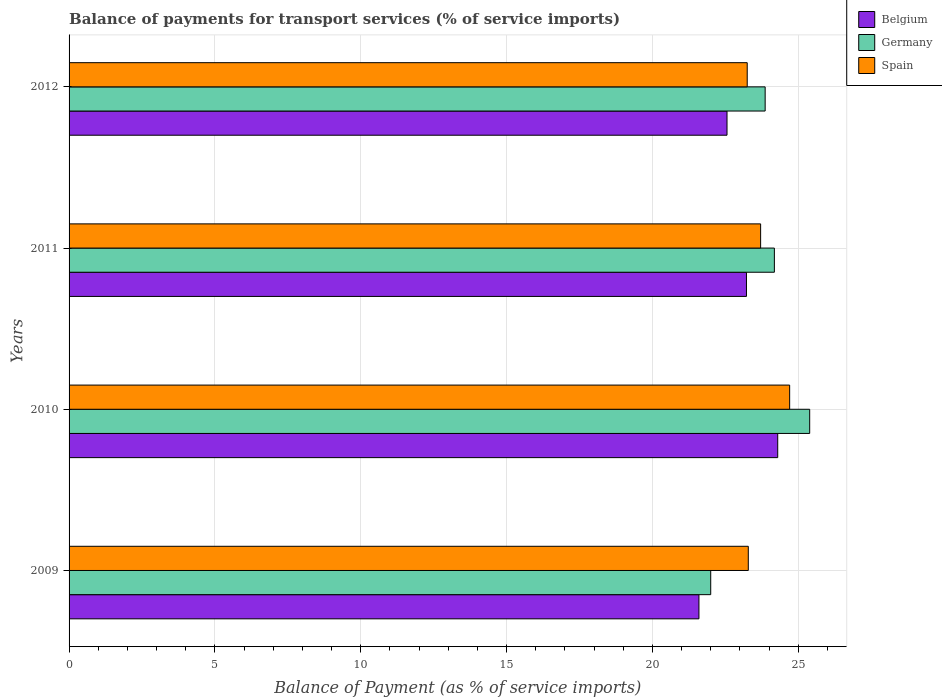How many different coloured bars are there?
Your response must be concise. 3. Are the number of bars per tick equal to the number of legend labels?
Give a very brief answer. Yes. Are the number of bars on each tick of the Y-axis equal?
Provide a succinct answer. Yes. How many bars are there on the 1st tick from the top?
Provide a succinct answer. 3. What is the balance of payments for transport services in Belgium in 2012?
Offer a terse response. 22.56. Across all years, what is the maximum balance of payments for transport services in Germany?
Make the answer very short. 25.39. Across all years, what is the minimum balance of payments for transport services in Belgium?
Provide a short and direct response. 21.6. What is the total balance of payments for transport services in Germany in the graph?
Ensure brevity in your answer.  95.45. What is the difference between the balance of payments for transport services in Spain in 2009 and that in 2010?
Your answer should be compact. -1.42. What is the difference between the balance of payments for transport services in Belgium in 2010 and the balance of payments for transport services in Spain in 2011?
Provide a short and direct response. 0.59. What is the average balance of payments for transport services in Spain per year?
Your response must be concise. 23.74. In the year 2010, what is the difference between the balance of payments for transport services in Germany and balance of payments for transport services in Belgium?
Provide a succinct answer. 1.1. In how many years, is the balance of payments for transport services in Spain greater than 4 %?
Your answer should be compact. 4. What is the ratio of the balance of payments for transport services in Belgium in 2010 to that in 2011?
Provide a short and direct response. 1.05. What is the difference between the highest and the second highest balance of payments for transport services in Spain?
Provide a short and direct response. 1. What is the difference between the highest and the lowest balance of payments for transport services in Belgium?
Your answer should be compact. 2.7. Is the sum of the balance of payments for transport services in Germany in 2009 and 2010 greater than the maximum balance of payments for transport services in Belgium across all years?
Give a very brief answer. Yes. Are the values on the major ticks of X-axis written in scientific E-notation?
Offer a terse response. No. How are the legend labels stacked?
Provide a succinct answer. Vertical. What is the title of the graph?
Give a very brief answer. Balance of payments for transport services (% of service imports). What is the label or title of the X-axis?
Your response must be concise. Balance of Payment (as % of service imports). What is the label or title of the Y-axis?
Your response must be concise. Years. What is the Balance of Payment (as % of service imports) of Belgium in 2009?
Make the answer very short. 21.6. What is the Balance of Payment (as % of service imports) of Germany in 2009?
Your response must be concise. 22. What is the Balance of Payment (as % of service imports) in Spain in 2009?
Provide a succinct answer. 23.29. What is the Balance of Payment (as % of service imports) in Belgium in 2010?
Offer a very short reply. 24.3. What is the Balance of Payment (as % of service imports) in Germany in 2010?
Keep it short and to the point. 25.39. What is the Balance of Payment (as % of service imports) in Spain in 2010?
Give a very brief answer. 24.71. What is the Balance of Payment (as % of service imports) in Belgium in 2011?
Make the answer very short. 23.23. What is the Balance of Payment (as % of service imports) in Germany in 2011?
Provide a short and direct response. 24.18. What is the Balance of Payment (as % of service imports) of Spain in 2011?
Keep it short and to the point. 23.71. What is the Balance of Payment (as % of service imports) in Belgium in 2012?
Offer a terse response. 22.56. What is the Balance of Payment (as % of service imports) in Germany in 2012?
Provide a short and direct response. 23.87. What is the Balance of Payment (as % of service imports) in Spain in 2012?
Your response must be concise. 23.25. Across all years, what is the maximum Balance of Payment (as % of service imports) of Belgium?
Provide a succinct answer. 24.3. Across all years, what is the maximum Balance of Payment (as % of service imports) in Germany?
Offer a very short reply. 25.39. Across all years, what is the maximum Balance of Payment (as % of service imports) of Spain?
Ensure brevity in your answer.  24.71. Across all years, what is the minimum Balance of Payment (as % of service imports) in Belgium?
Provide a short and direct response. 21.6. Across all years, what is the minimum Balance of Payment (as % of service imports) of Germany?
Make the answer very short. 22. Across all years, what is the minimum Balance of Payment (as % of service imports) of Spain?
Your answer should be compact. 23.25. What is the total Balance of Payment (as % of service imports) in Belgium in the graph?
Make the answer very short. 91.68. What is the total Balance of Payment (as % of service imports) in Germany in the graph?
Offer a terse response. 95.45. What is the total Balance of Payment (as % of service imports) of Spain in the graph?
Provide a short and direct response. 94.96. What is the difference between the Balance of Payment (as % of service imports) in Belgium in 2009 and that in 2010?
Your response must be concise. -2.7. What is the difference between the Balance of Payment (as % of service imports) in Germany in 2009 and that in 2010?
Provide a short and direct response. -3.39. What is the difference between the Balance of Payment (as % of service imports) in Spain in 2009 and that in 2010?
Your response must be concise. -1.42. What is the difference between the Balance of Payment (as % of service imports) in Belgium in 2009 and that in 2011?
Make the answer very short. -1.63. What is the difference between the Balance of Payment (as % of service imports) of Germany in 2009 and that in 2011?
Provide a succinct answer. -2.18. What is the difference between the Balance of Payment (as % of service imports) of Spain in 2009 and that in 2011?
Make the answer very short. -0.42. What is the difference between the Balance of Payment (as % of service imports) in Belgium in 2009 and that in 2012?
Give a very brief answer. -0.96. What is the difference between the Balance of Payment (as % of service imports) of Germany in 2009 and that in 2012?
Offer a very short reply. -1.87. What is the difference between the Balance of Payment (as % of service imports) in Spain in 2009 and that in 2012?
Your answer should be compact. 0.04. What is the difference between the Balance of Payment (as % of service imports) in Belgium in 2010 and that in 2011?
Make the answer very short. 1.07. What is the difference between the Balance of Payment (as % of service imports) of Germany in 2010 and that in 2011?
Provide a short and direct response. 1.21. What is the difference between the Balance of Payment (as % of service imports) in Spain in 2010 and that in 2011?
Your response must be concise. 1. What is the difference between the Balance of Payment (as % of service imports) in Belgium in 2010 and that in 2012?
Keep it short and to the point. 1.74. What is the difference between the Balance of Payment (as % of service imports) of Germany in 2010 and that in 2012?
Make the answer very short. 1.53. What is the difference between the Balance of Payment (as % of service imports) of Spain in 2010 and that in 2012?
Make the answer very short. 1.46. What is the difference between the Balance of Payment (as % of service imports) of Belgium in 2011 and that in 2012?
Offer a terse response. 0.67. What is the difference between the Balance of Payment (as % of service imports) of Germany in 2011 and that in 2012?
Make the answer very short. 0.32. What is the difference between the Balance of Payment (as % of service imports) of Spain in 2011 and that in 2012?
Provide a short and direct response. 0.46. What is the difference between the Balance of Payment (as % of service imports) in Belgium in 2009 and the Balance of Payment (as % of service imports) in Germany in 2010?
Offer a very short reply. -3.8. What is the difference between the Balance of Payment (as % of service imports) in Belgium in 2009 and the Balance of Payment (as % of service imports) in Spain in 2010?
Give a very brief answer. -3.11. What is the difference between the Balance of Payment (as % of service imports) in Germany in 2009 and the Balance of Payment (as % of service imports) in Spain in 2010?
Keep it short and to the point. -2.71. What is the difference between the Balance of Payment (as % of service imports) of Belgium in 2009 and the Balance of Payment (as % of service imports) of Germany in 2011?
Give a very brief answer. -2.59. What is the difference between the Balance of Payment (as % of service imports) in Belgium in 2009 and the Balance of Payment (as % of service imports) in Spain in 2011?
Offer a very short reply. -2.12. What is the difference between the Balance of Payment (as % of service imports) of Germany in 2009 and the Balance of Payment (as % of service imports) of Spain in 2011?
Ensure brevity in your answer.  -1.71. What is the difference between the Balance of Payment (as % of service imports) in Belgium in 2009 and the Balance of Payment (as % of service imports) in Germany in 2012?
Offer a very short reply. -2.27. What is the difference between the Balance of Payment (as % of service imports) of Belgium in 2009 and the Balance of Payment (as % of service imports) of Spain in 2012?
Your answer should be very brief. -1.66. What is the difference between the Balance of Payment (as % of service imports) of Germany in 2009 and the Balance of Payment (as % of service imports) of Spain in 2012?
Keep it short and to the point. -1.25. What is the difference between the Balance of Payment (as % of service imports) of Belgium in 2010 and the Balance of Payment (as % of service imports) of Germany in 2011?
Provide a short and direct response. 0.11. What is the difference between the Balance of Payment (as % of service imports) of Belgium in 2010 and the Balance of Payment (as % of service imports) of Spain in 2011?
Your response must be concise. 0.59. What is the difference between the Balance of Payment (as % of service imports) in Germany in 2010 and the Balance of Payment (as % of service imports) in Spain in 2011?
Give a very brief answer. 1.68. What is the difference between the Balance of Payment (as % of service imports) of Belgium in 2010 and the Balance of Payment (as % of service imports) of Germany in 2012?
Keep it short and to the point. 0.43. What is the difference between the Balance of Payment (as % of service imports) in Belgium in 2010 and the Balance of Payment (as % of service imports) in Spain in 2012?
Provide a succinct answer. 1.05. What is the difference between the Balance of Payment (as % of service imports) in Germany in 2010 and the Balance of Payment (as % of service imports) in Spain in 2012?
Ensure brevity in your answer.  2.14. What is the difference between the Balance of Payment (as % of service imports) of Belgium in 2011 and the Balance of Payment (as % of service imports) of Germany in 2012?
Ensure brevity in your answer.  -0.64. What is the difference between the Balance of Payment (as % of service imports) of Belgium in 2011 and the Balance of Payment (as % of service imports) of Spain in 2012?
Offer a terse response. -0.03. What is the average Balance of Payment (as % of service imports) of Belgium per year?
Provide a short and direct response. 22.92. What is the average Balance of Payment (as % of service imports) in Germany per year?
Offer a terse response. 23.86. What is the average Balance of Payment (as % of service imports) in Spain per year?
Keep it short and to the point. 23.74. In the year 2009, what is the difference between the Balance of Payment (as % of service imports) of Belgium and Balance of Payment (as % of service imports) of Germany?
Offer a very short reply. -0.4. In the year 2009, what is the difference between the Balance of Payment (as % of service imports) in Belgium and Balance of Payment (as % of service imports) in Spain?
Your response must be concise. -1.69. In the year 2009, what is the difference between the Balance of Payment (as % of service imports) in Germany and Balance of Payment (as % of service imports) in Spain?
Offer a very short reply. -1.29. In the year 2010, what is the difference between the Balance of Payment (as % of service imports) in Belgium and Balance of Payment (as % of service imports) in Germany?
Your answer should be compact. -1.1. In the year 2010, what is the difference between the Balance of Payment (as % of service imports) of Belgium and Balance of Payment (as % of service imports) of Spain?
Offer a very short reply. -0.41. In the year 2010, what is the difference between the Balance of Payment (as % of service imports) of Germany and Balance of Payment (as % of service imports) of Spain?
Offer a very short reply. 0.69. In the year 2011, what is the difference between the Balance of Payment (as % of service imports) in Belgium and Balance of Payment (as % of service imports) in Germany?
Provide a short and direct response. -0.96. In the year 2011, what is the difference between the Balance of Payment (as % of service imports) of Belgium and Balance of Payment (as % of service imports) of Spain?
Your answer should be very brief. -0.49. In the year 2011, what is the difference between the Balance of Payment (as % of service imports) in Germany and Balance of Payment (as % of service imports) in Spain?
Offer a terse response. 0.47. In the year 2012, what is the difference between the Balance of Payment (as % of service imports) of Belgium and Balance of Payment (as % of service imports) of Germany?
Keep it short and to the point. -1.31. In the year 2012, what is the difference between the Balance of Payment (as % of service imports) of Belgium and Balance of Payment (as % of service imports) of Spain?
Your response must be concise. -0.69. In the year 2012, what is the difference between the Balance of Payment (as % of service imports) of Germany and Balance of Payment (as % of service imports) of Spain?
Offer a terse response. 0.61. What is the ratio of the Balance of Payment (as % of service imports) of Belgium in 2009 to that in 2010?
Offer a very short reply. 0.89. What is the ratio of the Balance of Payment (as % of service imports) of Germany in 2009 to that in 2010?
Offer a very short reply. 0.87. What is the ratio of the Balance of Payment (as % of service imports) of Spain in 2009 to that in 2010?
Your answer should be compact. 0.94. What is the ratio of the Balance of Payment (as % of service imports) in Belgium in 2009 to that in 2011?
Keep it short and to the point. 0.93. What is the ratio of the Balance of Payment (as % of service imports) of Germany in 2009 to that in 2011?
Your answer should be compact. 0.91. What is the ratio of the Balance of Payment (as % of service imports) in Spain in 2009 to that in 2011?
Make the answer very short. 0.98. What is the ratio of the Balance of Payment (as % of service imports) of Belgium in 2009 to that in 2012?
Your answer should be compact. 0.96. What is the ratio of the Balance of Payment (as % of service imports) in Germany in 2009 to that in 2012?
Provide a succinct answer. 0.92. What is the ratio of the Balance of Payment (as % of service imports) of Spain in 2009 to that in 2012?
Your answer should be compact. 1. What is the ratio of the Balance of Payment (as % of service imports) of Belgium in 2010 to that in 2011?
Offer a terse response. 1.05. What is the ratio of the Balance of Payment (as % of service imports) in Germany in 2010 to that in 2011?
Your answer should be compact. 1.05. What is the ratio of the Balance of Payment (as % of service imports) in Spain in 2010 to that in 2011?
Your answer should be compact. 1.04. What is the ratio of the Balance of Payment (as % of service imports) of Belgium in 2010 to that in 2012?
Make the answer very short. 1.08. What is the ratio of the Balance of Payment (as % of service imports) in Germany in 2010 to that in 2012?
Offer a terse response. 1.06. What is the ratio of the Balance of Payment (as % of service imports) of Spain in 2010 to that in 2012?
Keep it short and to the point. 1.06. What is the ratio of the Balance of Payment (as % of service imports) of Belgium in 2011 to that in 2012?
Ensure brevity in your answer.  1.03. What is the ratio of the Balance of Payment (as % of service imports) of Germany in 2011 to that in 2012?
Provide a succinct answer. 1.01. What is the ratio of the Balance of Payment (as % of service imports) of Spain in 2011 to that in 2012?
Offer a terse response. 1.02. What is the difference between the highest and the second highest Balance of Payment (as % of service imports) of Belgium?
Keep it short and to the point. 1.07. What is the difference between the highest and the second highest Balance of Payment (as % of service imports) in Germany?
Ensure brevity in your answer.  1.21. What is the difference between the highest and the second highest Balance of Payment (as % of service imports) in Spain?
Provide a succinct answer. 1. What is the difference between the highest and the lowest Balance of Payment (as % of service imports) of Belgium?
Provide a succinct answer. 2.7. What is the difference between the highest and the lowest Balance of Payment (as % of service imports) of Germany?
Your response must be concise. 3.39. What is the difference between the highest and the lowest Balance of Payment (as % of service imports) of Spain?
Your answer should be compact. 1.46. 